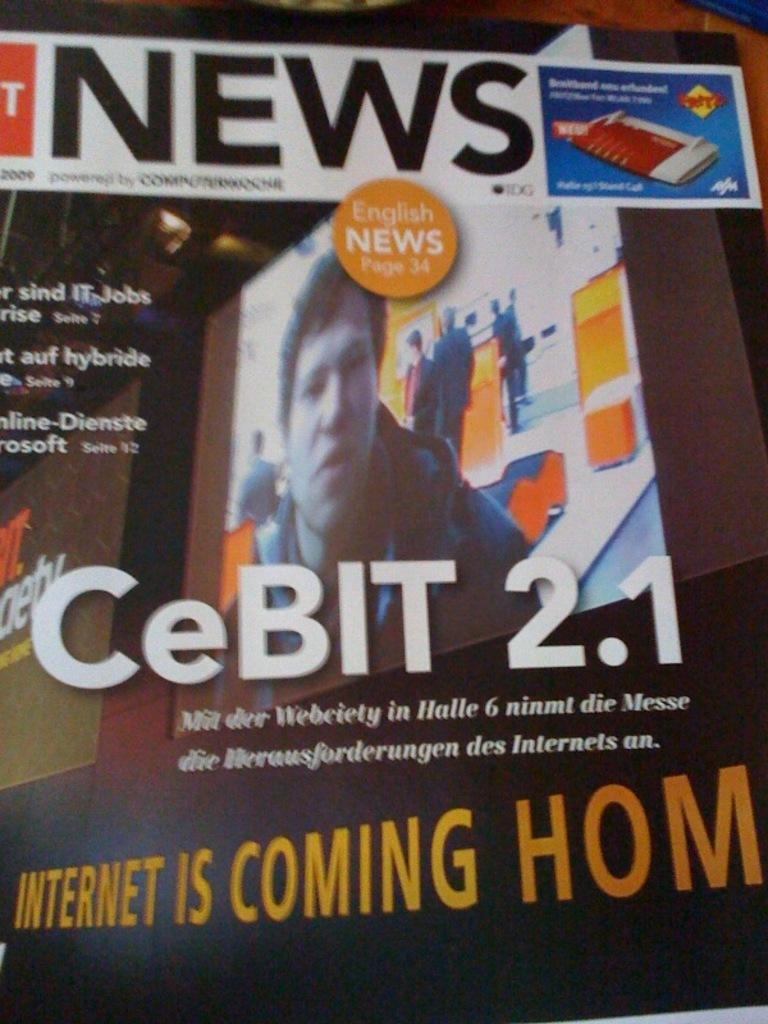<image>
Create a compact narrative representing the image presented. Screen for English news and the words "Internet is Coming Home" on the bottom. 